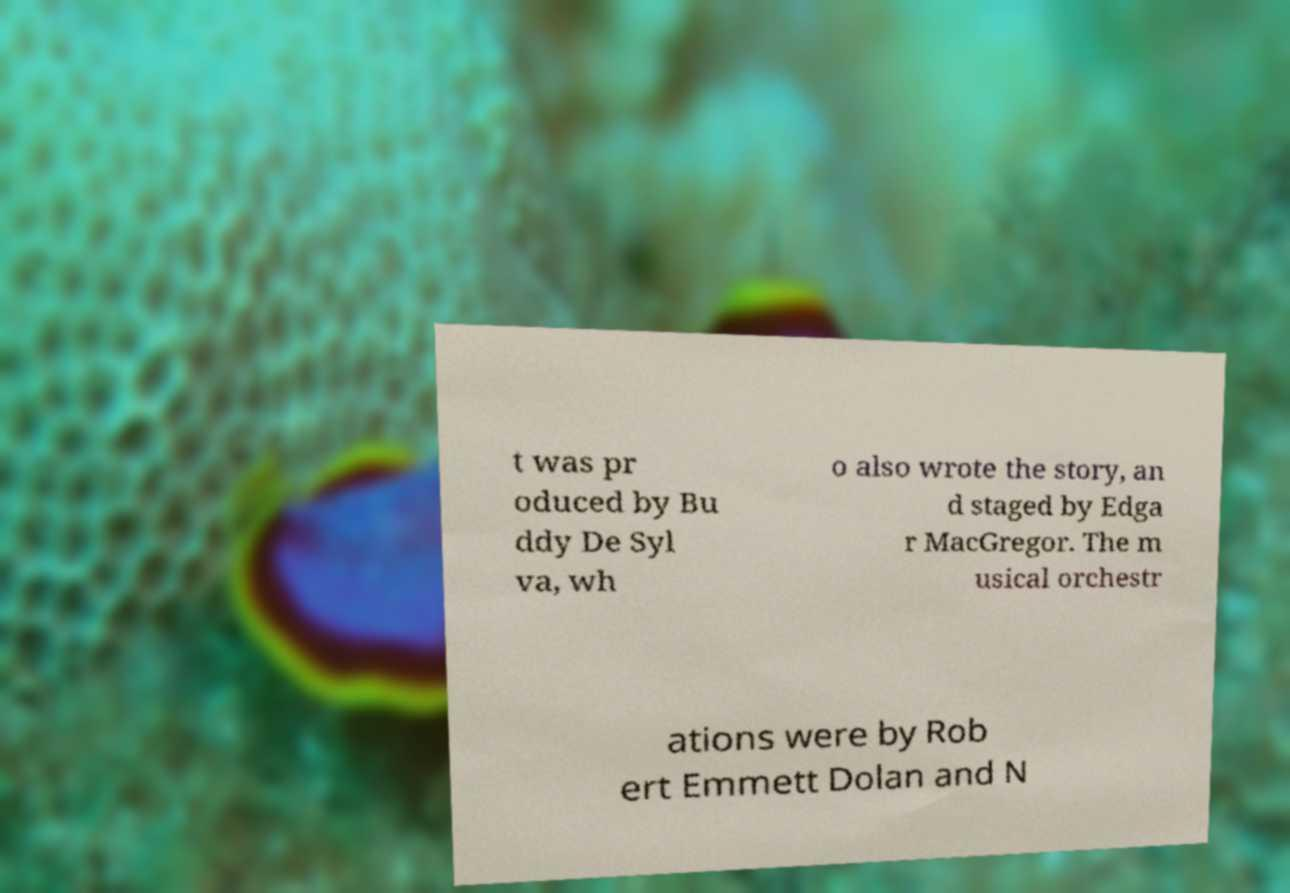Can you read and provide the text displayed in the image?This photo seems to have some interesting text. Can you extract and type it out for me? t was pr oduced by Bu ddy De Syl va, wh o also wrote the story, an d staged by Edga r MacGregor. The m usical orchestr ations were by Rob ert Emmett Dolan and N 